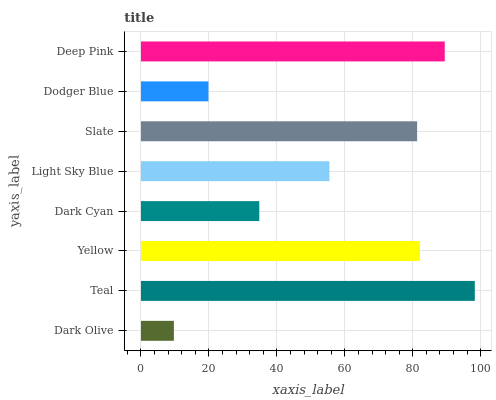Is Dark Olive the minimum?
Answer yes or no. Yes. Is Teal the maximum?
Answer yes or no. Yes. Is Yellow the minimum?
Answer yes or no. No. Is Yellow the maximum?
Answer yes or no. No. Is Teal greater than Yellow?
Answer yes or no. Yes. Is Yellow less than Teal?
Answer yes or no. Yes. Is Yellow greater than Teal?
Answer yes or no. No. Is Teal less than Yellow?
Answer yes or no. No. Is Slate the high median?
Answer yes or no. Yes. Is Light Sky Blue the low median?
Answer yes or no. Yes. Is Dodger Blue the high median?
Answer yes or no. No. Is Deep Pink the low median?
Answer yes or no. No. 